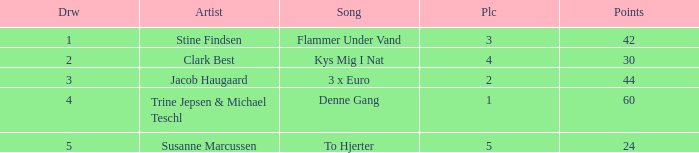What is the average Draw when the Place is larger than 5? None. Would you mind parsing the complete table? {'header': ['Drw', 'Artist', 'Song', 'Plc', 'Points'], 'rows': [['1', 'Stine Findsen', 'Flammer Under Vand', '3', '42'], ['2', 'Clark Best', 'Kys Mig I Nat', '4', '30'], ['3', 'Jacob Haugaard', '3 x Euro', '2', '44'], ['4', 'Trine Jepsen & Michael Teschl', 'Denne Gang', '1', '60'], ['5', 'Susanne Marcussen', 'To Hjerter', '5', '24']]} 